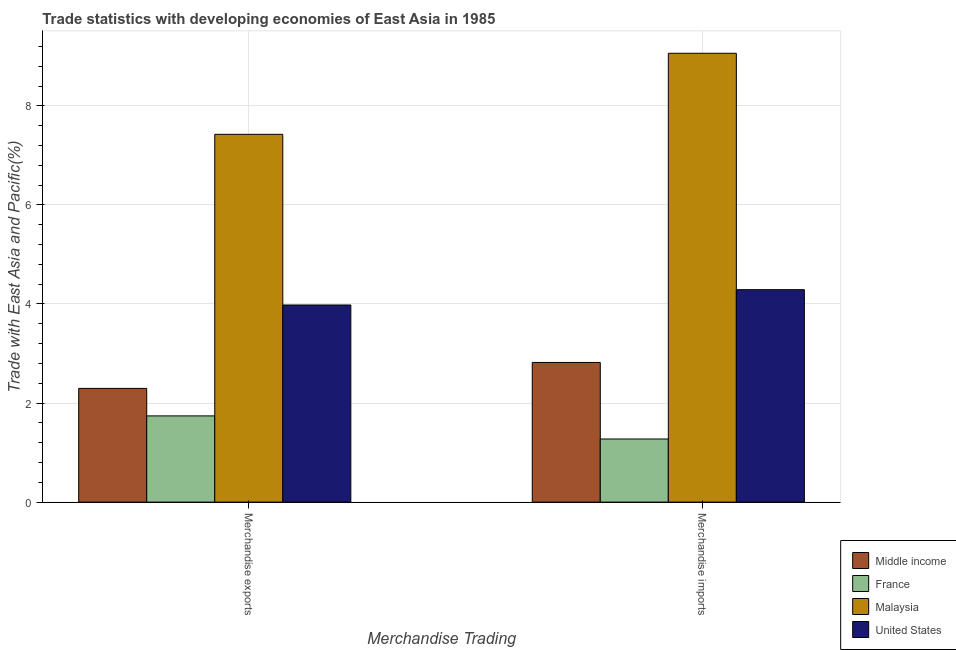How many groups of bars are there?
Your response must be concise. 2. Are the number of bars per tick equal to the number of legend labels?
Keep it short and to the point. Yes. What is the merchandise exports in United States?
Make the answer very short. 3.98. Across all countries, what is the maximum merchandise exports?
Your response must be concise. 7.43. Across all countries, what is the minimum merchandise exports?
Your response must be concise. 1.74. In which country was the merchandise imports maximum?
Keep it short and to the point. Malaysia. In which country was the merchandise exports minimum?
Make the answer very short. France. What is the total merchandise imports in the graph?
Provide a short and direct response. 17.45. What is the difference between the merchandise imports in Malaysia and that in Middle income?
Your answer should be very brief. 6.24. What is the difference between the merchandise exports in France and the merchandise imports in Middle income?
Your answer should be compact. -1.08. What is the average merchandise imports per country?
Provide a succinct answer. 4.36. What is the difference between the merchandise imports and merchandise exports in United States?
Provide a succinct answer. 0.31. What is the ratio of the merchandise exports in United States to that in Malaysia?
Give a very brief answer. 0.54. Is the merchandise exports in United States less than that in France?
Give a very brief answer. No. In how many countries, is the merchandise imports greater than the average merchandise imports taken over all countries?
Your response must be concise. 1. What does the 1st bar from the left in Merchandise exports represents?
Make the answer very short. Middle income. What does the 4th bar from the right in Merchandise imports represents?
Provide a succinct answer. Middle income. How many bars are there?
Your response must be concise. 8. Are all the bars in the graph horizontal?
Your answer should be compact. No. Does the graph contain any zero values?
Your response must be concise. No. How many legend labels are there?
Your answer should be compact. 4. What is the title of the graph?
Your answer should be very brief. Trade statistics with developing economies of East Asia in 1985. What is the label or title of the X-axis?
Ensure brevity in your answer.  Merchandise Trading. What is the label or title of the Y-axis?
Your answer should be very brief. Trade with East Asia and Pacific(%). What is the Trade with East Asia and Pacific(%) of Middle income in Merchandise exports?
Provide a succinct answer. 2.3. What is the Trade with East Asia and Pacific(%) in France in Merchandise exports?
Keep it short and to the point. 1.74. What is the Trade with East Asia and Pacific(%) of Malaysia in Merchandise exports?
Your response must be concise. 7.43. What is the Trade with East Asia and Pacific(%) in United States in Merchandise exports?
Ensure brevity in your answer.  3.98. What is the Trade with East Asia and Pacific(%) in Middle income in Merchandise imports?
Offer a very short reply. 2.82. What is the Trade with East Asia and Pacific(%) in France in Merchandise imports?
Provide a short and direct response. 1.27. What is the Trade with East Asia and Pacific(%) in Malaysia in Merchandise imports?
Ensure brevity in your answer.  9.06. What is the Trade with East Asia and Pacific(%) of United States in Merchandise imports?
Your answer should be very brief. 4.29. Across all Merchandise Trading, what is the maximum Trade with East Asia and Pacific(%) in Middle income?
Provide a short and direct response. 2.82. Across all Merchandise Trading, what is the maximum Trade with East Asia and Pacific(%) of France?
Make the answer very short. 1.74. Across all Merchandise Trading, what is the maximum Trade with East Asia and Pacific(%) in Malaysia?
Offer a very short reply. 9.06. Across all Merchandise Trading, what is the maximum Trade with East Asia and Pacific(%) in United States?
Make the answer very short. 4.29. Across all Merchandise Trading, what is the minimum Trade with East Asia and Pacific(%) in Middle income?
Your response must be concise. 2.3. Across all Merchandise Trading, what is the minimum Trade with East Asia and Pacific(%) in France?
Your answer should be very brief. 1.27. Across all Merchandise Trading, what is the minimum Trade with East Asia and Pacific(%) of Malaysia?
Ensure brevity in your answer.  7.43. Across all Merchandise Trading, what is the minimum Trade with East Asia and Pacific(%) in United States?
Make the answer very short. 3.98. What is the total Trade with East Asia and Pacific(%) in Middle income in the graph?
Your response must be concise. 5.12. What is the total Trade with East Asia and Pacific(%) in France in the graph?
Provide a succinct answer. 3.02. What is the total Trade with East Asia and Pacific(%) in Malaysia in the graph?
Give a very brief answer. 16.49. What is the total Trade with East Asia and Pacific(%) in United States in the graph?
Offer a very short reply. 8.27. What is the difference between the Trade with East Asia and Pacific(%) of Middle income in Merchandise exports and that in Merchandise imports?
Your response must be concise. -0.52. What is the difference between the Trade with East Asia and Pacific(%) in France in Merchandise exports and that in Merchandise imports?
Give a very brief answer. 0.47. What is the difference between the Trade with East Asia and Pacific(%) of Malaysia in Merchandise exports and that in Merchandise imports?
Your answer should be compact. -1.64. What is the difference between the Trade with East Asia and Pacific(%) in United States in Merchandise exports and that in Merchandise imports?
Provide a short and direct response. -0.31. What is the difference between the Trade with East Asia and Pacific(%) of Middle income in Merchandise exports and the Trade with East Asia and Pacific(%) of France in Merchandise imports?
Your answer should be very brief. 1.02. What is the difference between the Trade with East Asia and Pacific(%) of Middle income in Merchandise exports and the Trade with East Asia and Pacific(%) of Malaysia in Merchandise imports?
Your answer should be compact. -6.77. What is the difference between the Trade with East Asia and Pacific(%) in Middle income in Merchandise exports and the Trade with East Asia and Pacific(%) in United States in Merchandise imports?
Your answer should be compact. -1.99. What is the difference between the Trade with East Asia and Pacific(%) of France in Merchandise exports and the Trade with East Asia and Pacific(%) of Malaysia in Merchandise imports?
Your answer should be compact. -7.32. What is the difference between the Trade with East Asia and Pacific(%) of France in Merchandise exports and the Trade with East Asia and Pacific(%) of United States in Merchandise imports?
Give a very brief answer. -2.55. What is the difference between the Trade with East Asia and Pacific(%) in Malaysia in Merchandise exports and the Trade with East Asia and Pacific(%) in United States in Merchandise imports?
Keep it short and to the point. 3.14. What is the average Trade with East Asia and Pacific(%) in Middle income per Merchandise Trading?
Your answer should be compact. 2.56. What is the average Trade with East Asia and Pacific(%) in France per Merchandise Trading?
Provide a short and direct response. 1.51. What is the average Trade with East Asia and Pacific(%) of Malaysia per Merchandise Trading?
Make the answer very short. 8.24. What is the average Trade with East Asia and Pacific(%) of United States per Merchandise Trading?
Your response must be concise. 4.13. What is the difference between the Trade with East Asia and Pacific(%) in Middle income and Trade with East Asia and Pacific(%) in France in Merchandise exports?
Give a very brief answer. 0.56. What is the difference between the Trade with East Asia and Pacific(%) in Middle income and Trade with East Asia and Pacific(%) in Malaysia in Merchandise exports?
Provide a short and direct response. -5.13. What is the difference between the Trade with East Asia and Pacific(%) in Middle income and Trade with East Asia and Pacific(%) in United States in Merchandise exports?
Make the answer very short. -1.68. What is the difference between the Trade with East Asia and Pacific(%) in France and Trade with East Asia and Pacific(%) in Malaysia in Merchandise exports?
Your answer should be very brief. -5.68. What is the difference between the Trade with East Asia and Pacific(%) in France and Trade with East Asia and Pacific(%) in United States in Merchandise exports?
Provide a succinct answer. -2.24. What is the difference between the Trade with East Asia and Pacific(%) in Malaysia and Trade with East Asia and Pacific(%) in United States in Merchandise exports?
Your answer should be compact. 3.45. What is the difference between the Trade with East Asia and Pacific(%) of Middle income and Trade with East Asia and Pacific(%) of France in Merchandise imports?
Provide a short and direct response. 1.55. What is the difference between the Trade with East Asia and Pacific(%) in Middle income and Trade with East Asia and Pacific(%) in Malaysia in Merchandise imports?
Give a very brief answer. -6.24. What is the difference between the Trade with East Asia and Pacific(%) in Middle income and Trade with East Asia and Pacific(%) in United States in Merchandise imports?
Provide a succinct answer. -1.47. What is the difference between the Trade with East Asia and Pacific(%) in France and Trade with East Asia and Pacific(%) in Malaysia in Merchandise imports?
Give a very brief answer. -7.79. What is the difference between the Trade with East Asia and Pacific(%) in France and Trade with East Asia and Pacific(%) in United States in Merchandise imports?
Make the answer very short. -3.01. What is the difference between the Trade with East Asia and Pacific(%) of Malaysia and Trade with East Asia and Pacific(%) of United States in Merchandise imports?
Your response must be concise. 4.77. What is the ratio of the Trade with East Asia and Pacific(%) in Middle income in Merchandise exports to that in Merchandise imports?
Offer a very short reply. 0.81. What is the ratio of the Trade with East Asia and Pacific(%) in France in Merchandise exports to that in Merchandise imports?
Offer a very short reply. 1.37. What is the ratio of the Trade with East Asia and Pacific(%) of Malaysia in Merchandise exports to that in Merchandise imports?
Offer a very short reply. 0.82. What is the ratio of the Trade with East Asia and Pacific(%) of United States in Merchandise exports to that in Merchandise imports?
Keep it short and to the point. 0.93. What is the difference between the highest and the second highest Trade with East Asia and Pacific(%) in Middle income?
Your answer should be very brief. 0.52. What is the difference between the highest and the second highest Trade with East Asia and Pacific(%) in France?
Provide a short and direct response. 0.47. What is the difference between the highest and the second highest Trade with East Asia and Pacific(%) in Malaysia?
Provide a succinct answer. 1.64. What is the difference between the highest and the second highest Trade with East Asia and Pacific(%) in United States?
Your answer should be very brief. 0.31. What is the difference between the highest and the lowest Trade with East Asia and Pacific(%) in Middle income?
Give a very brief answer. 0.52. What is the difference between the highest and the lowest Trade with East Asia and Pacific(%) in France?
Provide a short and direct response. 0.47. What is the difference between the highest and the lowest Trade with East Asia and Pacific(%) of Malaysia?
Keep it short and to the point. 1.64. What is the difference between the highest and the lowest Trade with East Asia and Pacific(%) of United States?
Offer a terse response. 0.31. 